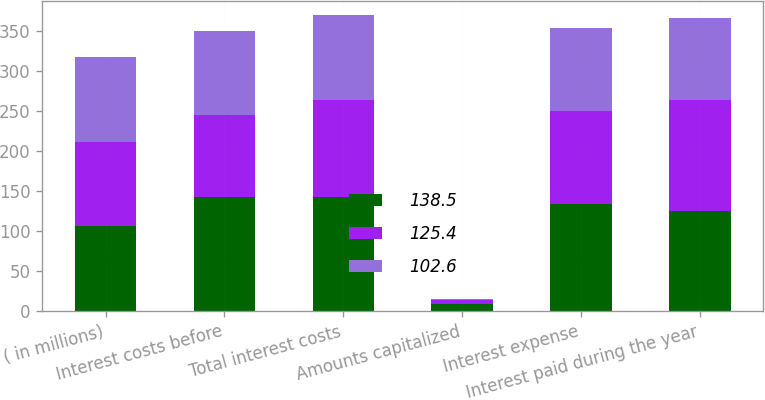Convert chart. <chart><loc_0><loc_0><loc_500><loc_500><stacked_bar_chart><ecel><fcel>( in millions)<fcel>Interest costs before<fcel>Total interest costs<fcel>Amounts capitalized<fcel>Interest expense<fcel>Interest paid during the year<nl><fcel>138.5<fcel>105.8<fcel>142.5<fcel>142.5<fcel>8.1<fcel>134.4<fcel>125.4<nl><fcel>125.4<fcel>105.8<fcel>102.4<fcel>121.7<fcel>5.3<fcel>116.4<fcel>138.5<nl><fcel>102.6<fcel>105.8<fcel>105.8<fcel>105.8<fcel>2.1<fcel>103.7<fcel>102.6<nl></chart> 